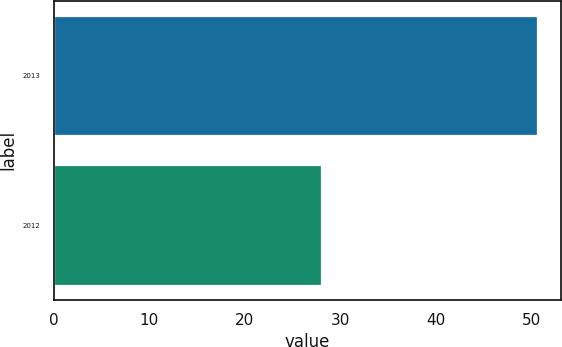Convert chart to OTSL. <chart><loc_0><loc_0><loc_500><loc_500><bar_chart><fcel>2013<fcel>2012<nl><fcel>50.6<fcel>28.01<nl></chart> 